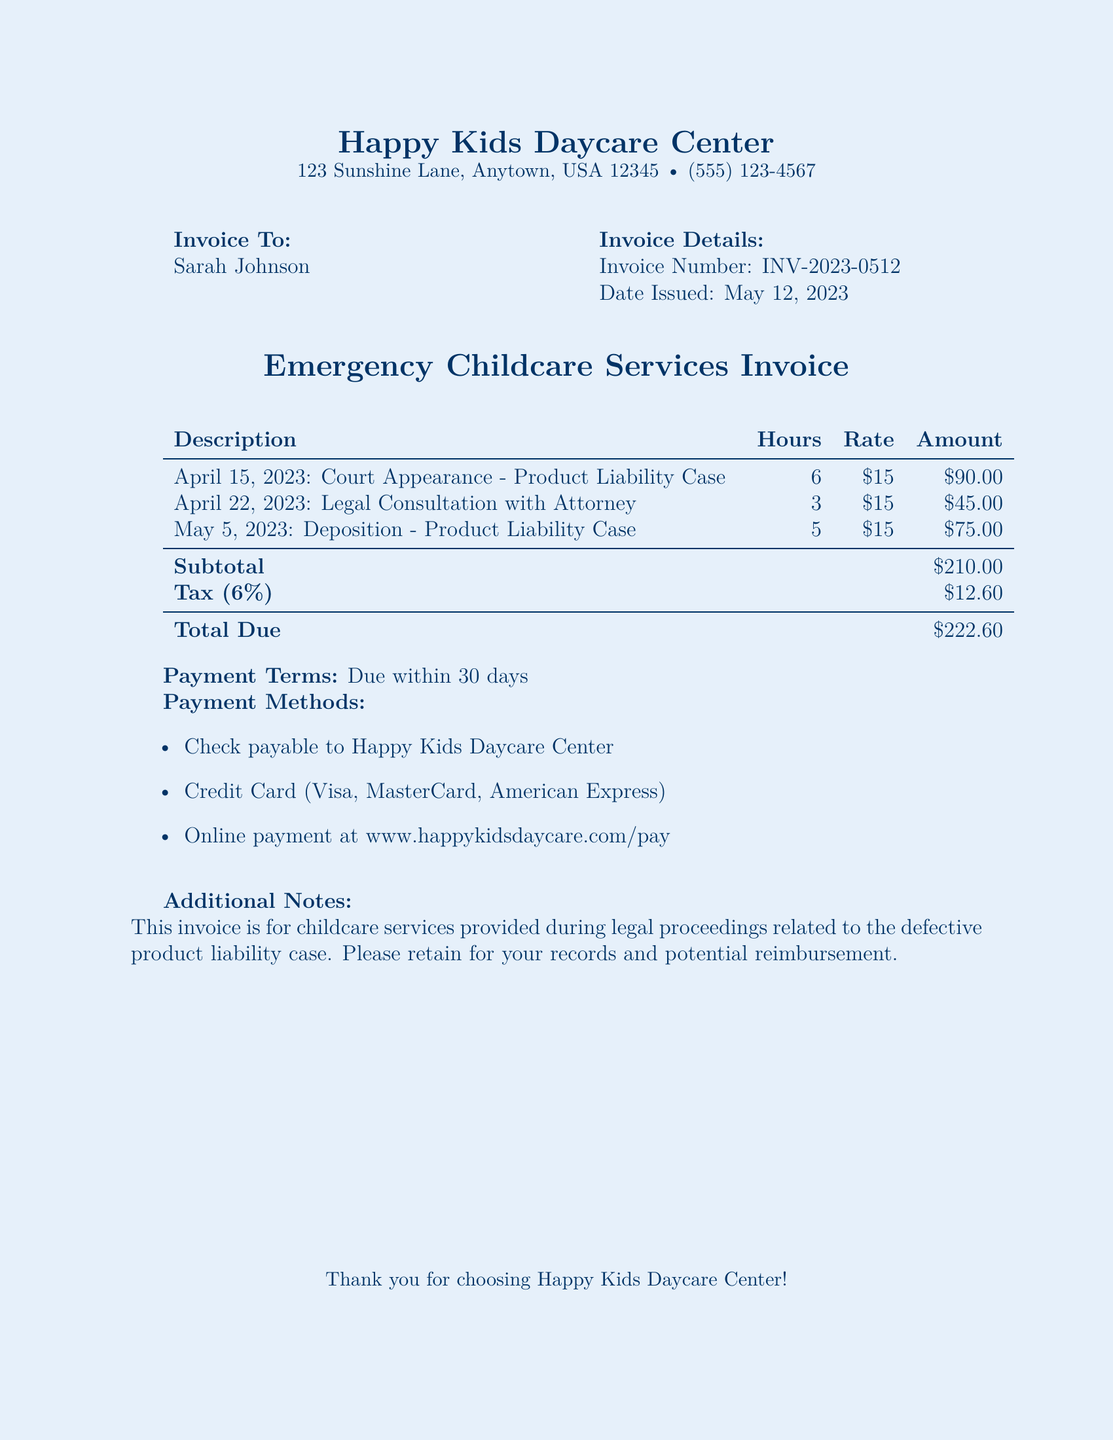What is the invoice number? The invoice number is specified clearly in the document under Invoice Details.
Answer: INV-2023-0512 What is the total due? The total due is listed at the bottom of the invoice, which includes all amounts calculated.
Answer: $222.60 Who is the invoice issued to? The name of the person to whom the invoice is issued is mentioned at the top of the document.
Answer: Sarah Johnson What is the date issued? The date issued is provided as part of the invoice details, indicating when the document was created.
Answer: May 12, 2023 How many total hours of childcare are billed? The total hours can be found by adding up the hours listed for each service in the invoice.
Answer: 14 What is the tax percentage applied? The tax percentage is specified in the tax section of the invoice.
Answer: 6% What type of services are invoiced? The document outlines the types of services provided during legal proceedings related to a specific case.
Answer: Emergency Childcare Services What payment methods are accepted? The document lists the acceptable payment methods for settling the invoice.
Answer: Check, Credit Card, Online payment What is the subtotal amount? The subtotal amount is calculated before tax and is listed in the invoice.
Answer: $210.00 